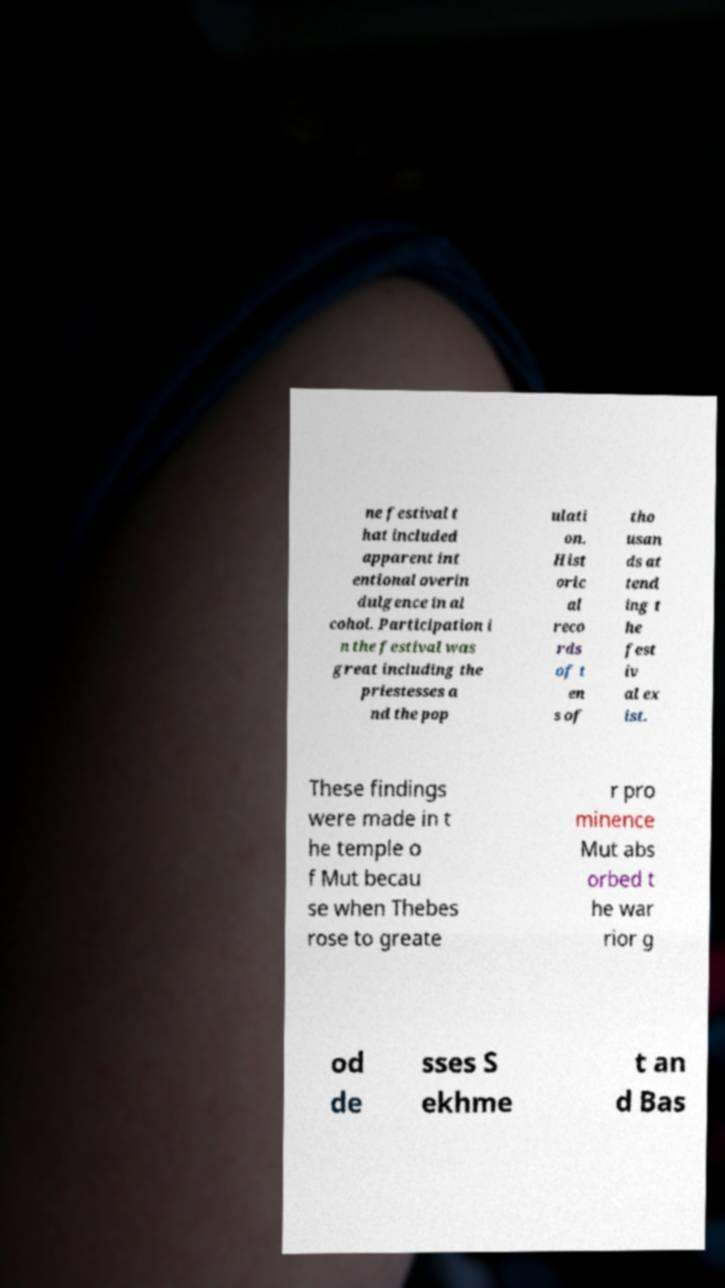For documentation purposes, I need the text within this image transcribed. Could you provide that? ne festival t hat included apparent int entional overin dulgence in al cohol. Participation i n the festival was great including the priestesses a nd the pop ulati on. Hist oric al reco rds of t en s of tho usan ds at tend ing t he fest iv al ex ist. These findings were made in t he temple o f Mut becau se when Thebes rose to greate r pro minence Mut abs orbed t he war rior g od de sses S ekhme t an d Bas 